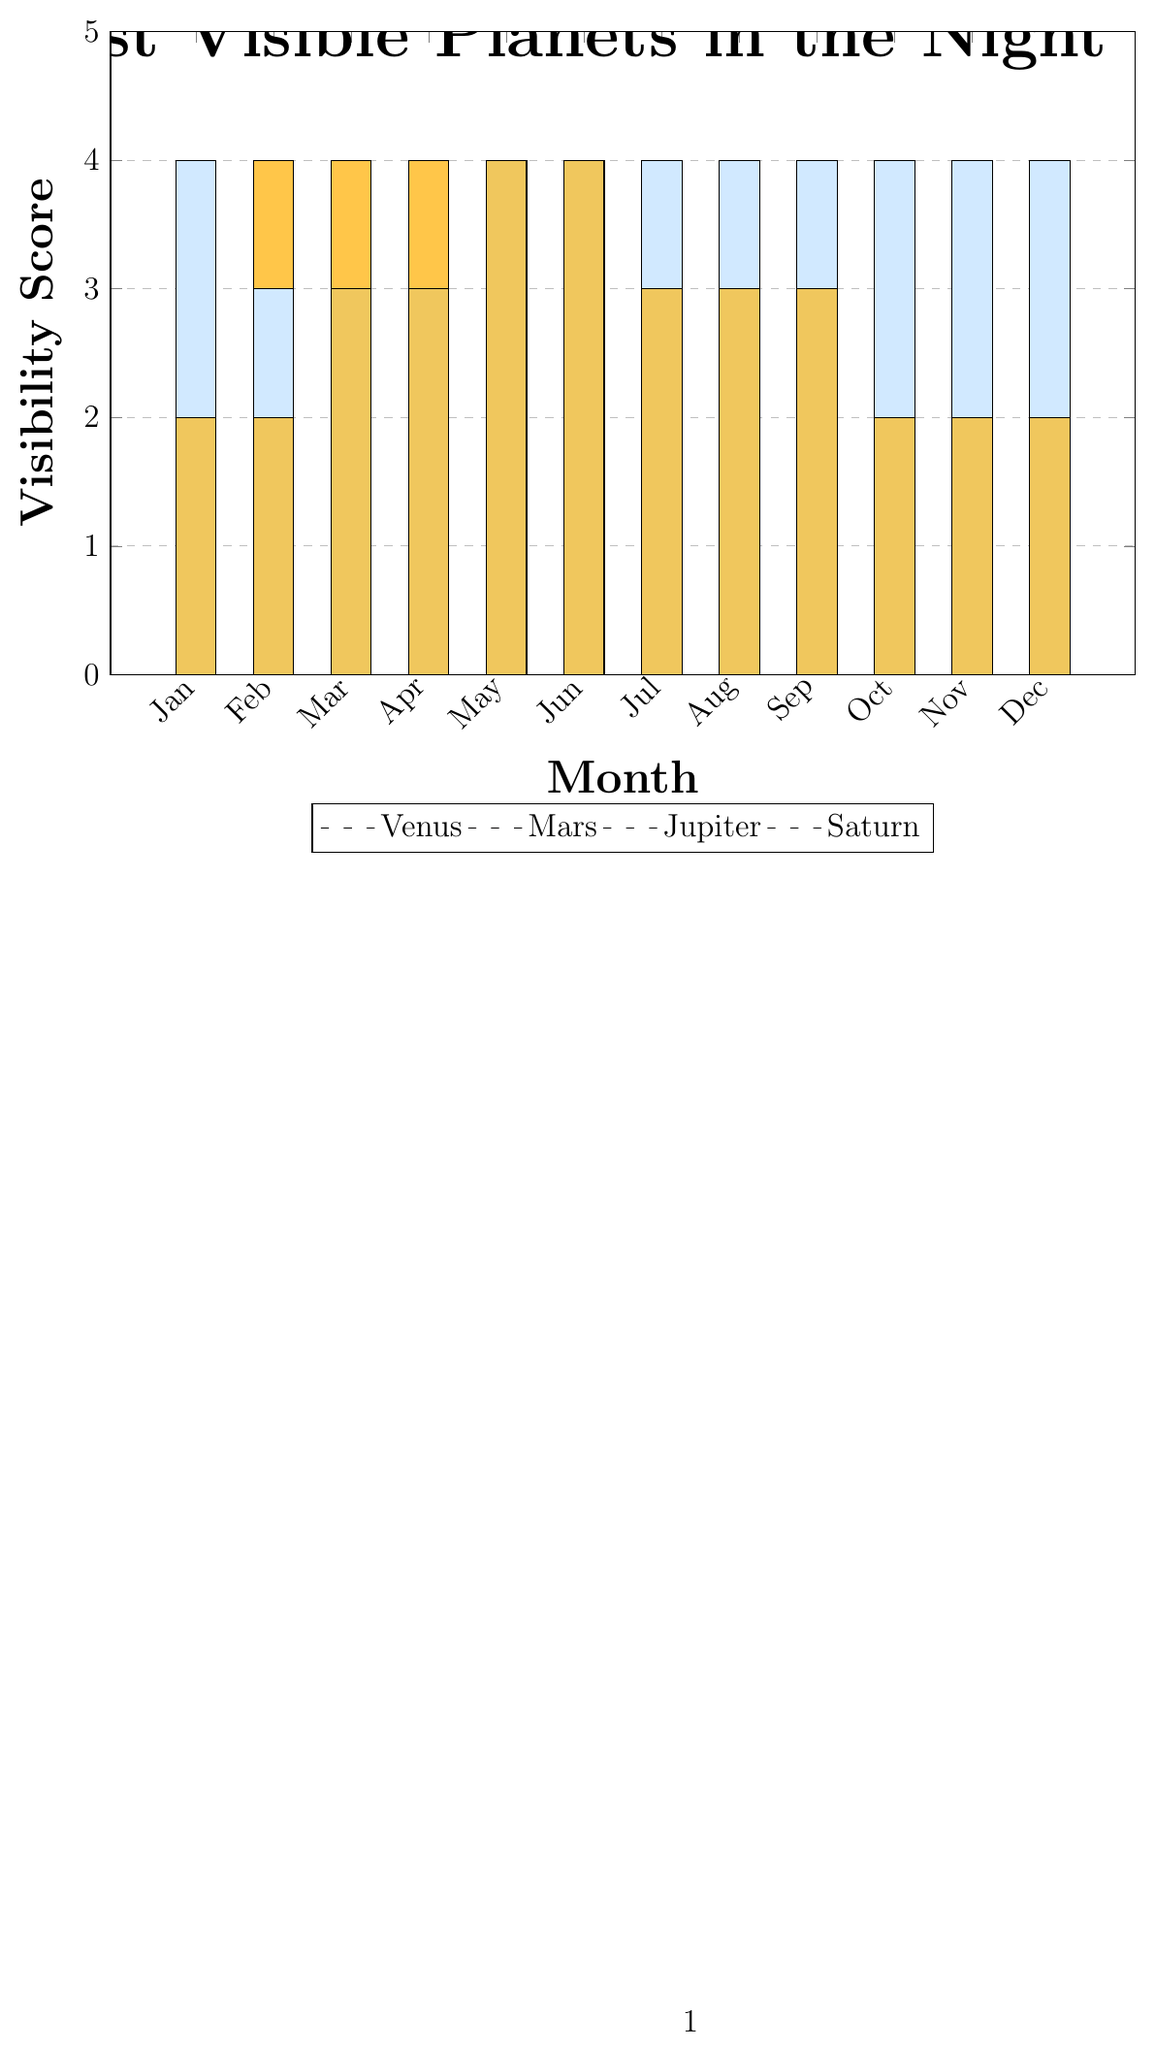What's the most visible planet in January? Look at the heights of the bars for January. The highest bar represents Jupiter with a visibility score of 4.
Answer: Jupiter Which month is Mars most visible? Mars's visibility is represented by the red bars. The highest red bar corresponds to August, where the visibility score is 4.
Answer: August What is the pattern of Venus’s visibility throughout the year? The yellow bars represent Venus. They start at 3 in January, peak at 4 from February to April, decrease to 1 in July and August, and then rise back to 3 towards the end of the year.
Answer: Peaks from Feb-Apr, drops in Jul-Aug, stable otherwise Which planet has the most consistent visibility score across the months? Jupiter's visibility score (light blue bars) is very consistent, being 4 most of the months except in February, March, April, and May, where it slightly drops to 2-3.
Answer: Jupiter During which month is Saturn most visible, and can any other planet be seen with equal visibility in that month? Saturn (gold bars) is most visible in May and June with a visibility score of 4. No other planet has a visibility score of 4 in these months.
Answer: May and June, No Add the visibility scores of all planets in July. Sum the heights of all bars in July: Venus (1) + Mars (3) + Jupiter (4) + Saturn (3) = 11.
Answer: 11 Which planet has the lowest visibility score in March, and what is it? The shortest bars in March are for Venus (4), Mars (1), Jupiter (2), and Saturn (3). The shortest bar is for Mars with a visibility score of 1.
Answer: Mars, 1 Compare the visibility scores of Saturn in January and September. In January, Saturn’s visibility score is 2 (gold bar). In September, it is 3 (gold bar).
Answer: January: 2, September: 3 What is the difference in visibility score between Venus and Mars in June? Venus's visibility in June is 2, and Mars's visibility is 2. The difference is 0 (2 - 2).
Answer: 0 In which months do Venus and Jupiter have an equal visibility score? Compare the yellow and light blue bars. They are equal in February (4), April (2), July (4), and September (2).
Answer: July 